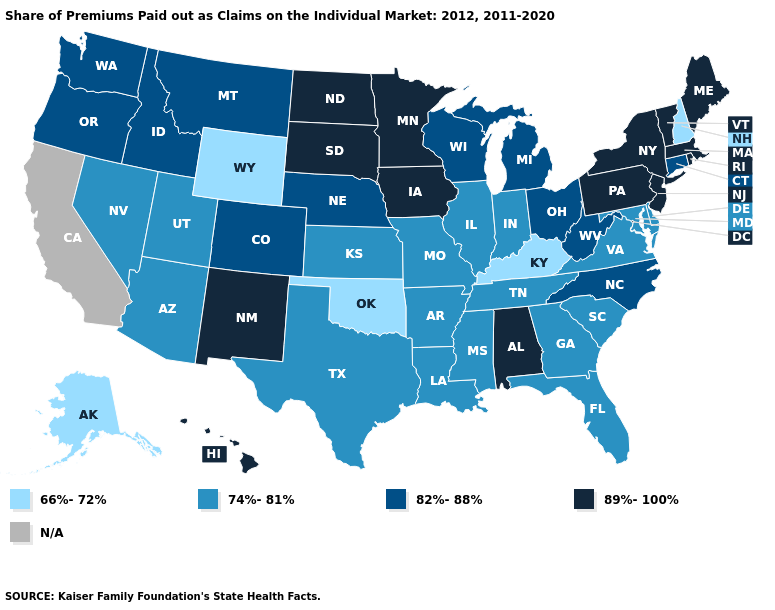Name the states that have a value in the range N/A?
Short answer required. California. Name the states that have a value in the range 82%-88%?
Give a very brief answer. Colorado, Connecticut, Idaho, Michigan, Montana, Nebraska, North Carolina, Ohio, Oregon, Washington, West Virginia, Wisconsin. Name the states that have a value in the range 74%-81%?
Concise answer only. Arizona, Arkansas, Delaware, Florida, Georgia, Illinois, Indiana, Kansas, Louisiana, Maryland, Mississippi, Missouri, Nevada, South Carolina, Tennessee, Texas, Utah, Virginia. Does the map have missing data?
Give a very brief answer. Yes. What is the lowest value in the MidWest?
Concise answer only. 74%-81%. What is the highest value in the USA?
Give a very brief answer. 89%-100%. What is the lowest value in the USA?
Quick response, please. 66%-72%. Is the legend a continuous bar?
Quick response, please. No. Does the map have missing data?
Concise answer only. Yes. Does the map have missing data?
Answer briefly. Yes. Is the legend a continuous bar?
Be succinct. No. What is the value of Utah?
Write a very short answer. 74%-81%. Name the states that have a value in the range 74%-81%?
Keep it brief. Arizona, Arkansas, Delaware, Florida, Georgia, Illinois, Indiana, Kansas, Louisiana, Maryland, Mississippi, Missouri, Nevada, South Carolina, Tennessee, Texas, Utah, Virginia. Which states have the lowest value in the USA?
Answer briefly. Alaska, Kentucky, New Hampshire, Oklahoma, Wyoming. 